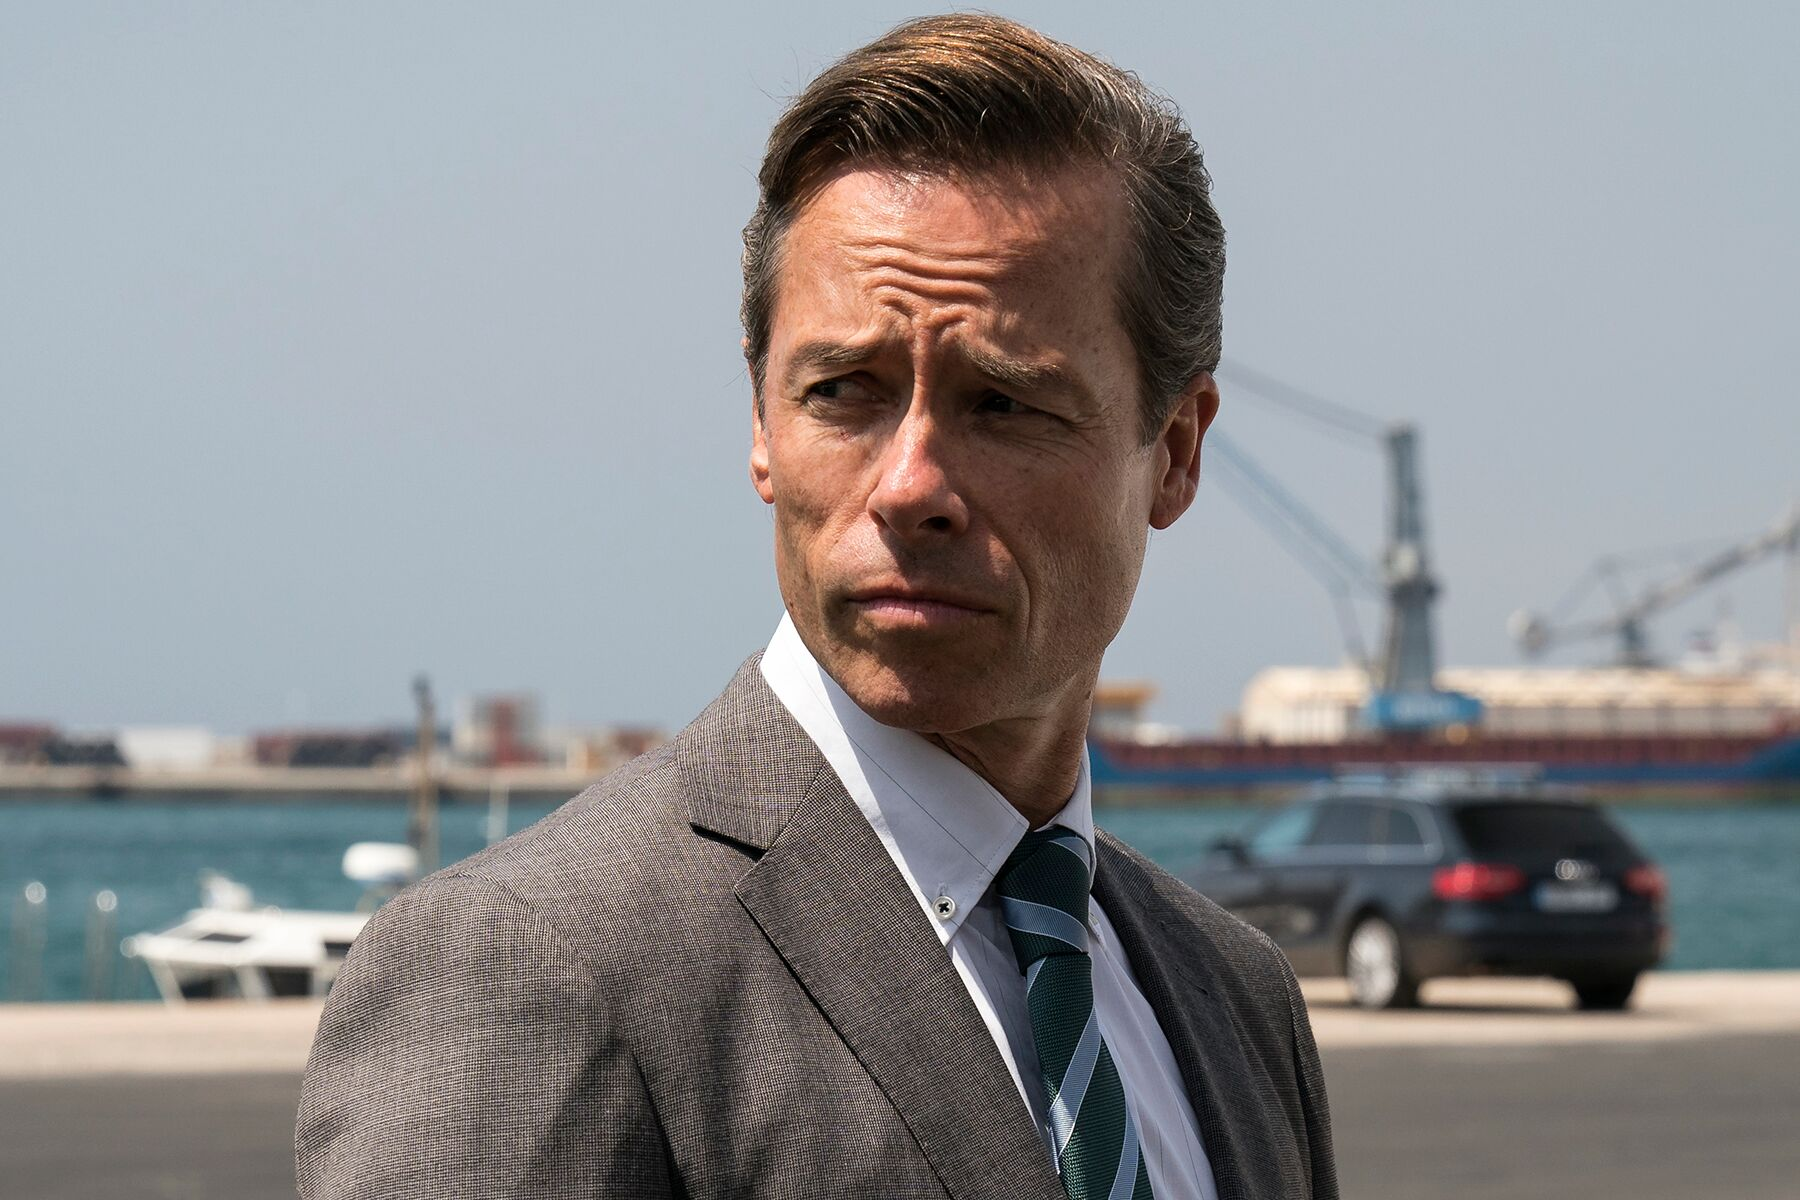What could this scene be representative of in a larger storyline? This scene might represent a crucial decision-making moment for the character portrayed. The professional attire and serious demeanor suggest a person who holds a position of power or influence. The maritime background could imply that the scene is set in a context of global trade, corporate dealings, or even an undercover operation. The character could be strategizing about an important business transaction, dealing with a crisis, or contemplating the ramifications of a recent event in the storyline. This setting adds depth to the plot, indicating that the decisions made here could have far-reaching implications. 